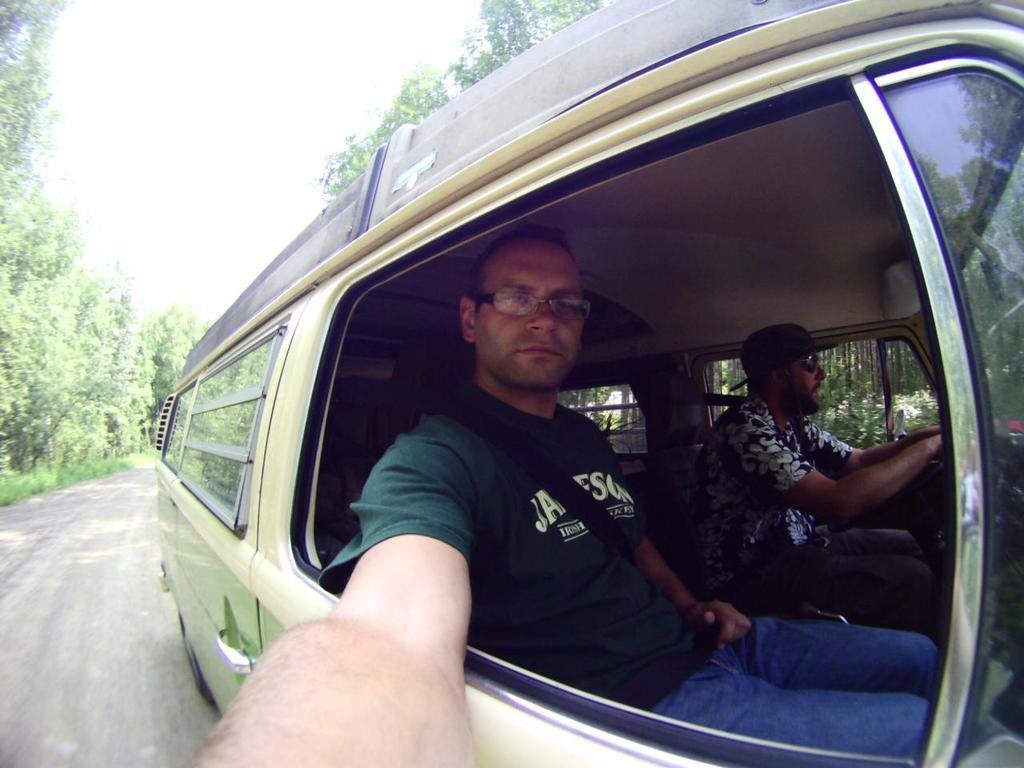How many people are in the image? There are two persons in the image. What are the persons wearing that can be seen in the image? The persons are wearing glasses. Where are the persons located in the image? The persons are sitting inside a vehicle. What is the vehicle doing in the image? The vehicle is passing on a road. What can be seen in the background of the image? There are trees and the sky visible in the background of the image. How many dogs are visible in the image? There are no dogs present in the image. What type of tooth is being used by the persons in the image? The persons are wearing glasses, not using teeth, in the image. 